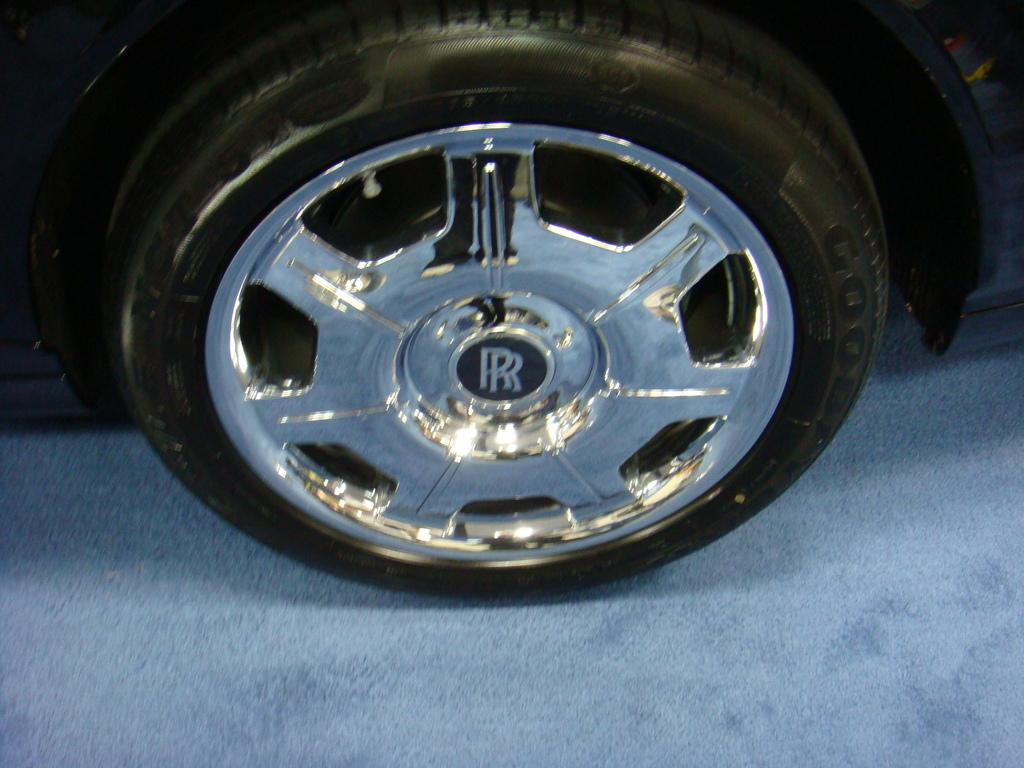What is the main subject of the image? The main subject of the image is a tire of a vehicle. Where is the tire located in the image? The tire is in the center of the image. Is there any additional information about the tire? Yes, there is a logo on the tire. How many kittens are playing with the tire in the image? There are no kittens present in the image; it only features a tire with a logo. Can you hear someone coughing in the image? There is no sound or indication of coughing in the image, as it is a still image of a tire. 